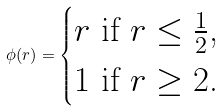Convert formula to latex. <formula><loc_0><loc_0><loc_500><loc_500>\phi ( r ) = \begin{cases} r \text { if $r \leq \frac{1}{2}$,} \\ 1 \text { if $r \geq 2$.} \\ \end{cases}</formula> 